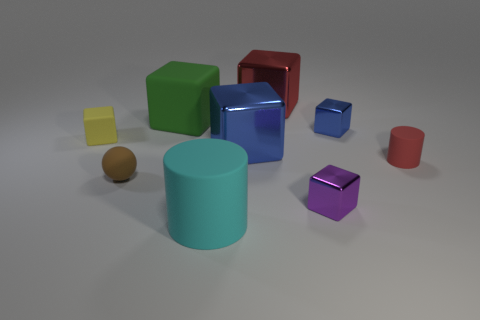What material do the objects in the image appear to be made of? The objects in the image appear to be made of a smooth, matte material, similar to rubber or plastic, which is common in computer-generated imagery for visual simplicity and to enhance the colors. 